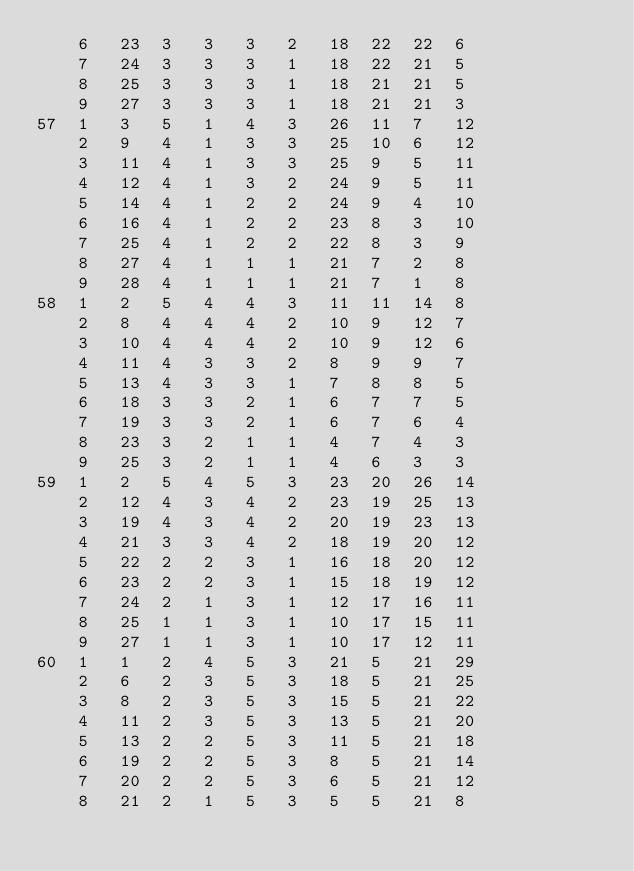<code> <loc_0><loc_0><loc_500><loc_500><_ObjectiveC_>	6	23	3	3	3	2	18	22	22	6	
	7	24	3	3	3	1	18	22	21	5	
	8	25	3	3	3	1	18	21	21	5	
	9	27	3	3	3	1	18	21	21	3	
57	1	3	5	1	4	3	26	11	7	12	
	2	9	4	1	3	3	25	10	6	12	
	3	11	4	1	3	3	25	9	5	11	
	4	12	4	1	3	2	24	9	5	11	
	5	14	4	1	2	2	24	9	4	10	
	6	16	4	1	2	2	23	8	3	10	
	7	25	4	1	2	2	22	8	3	9	
	8	27	4	1	1	1	21	7	2	8	
	9	28	4	1	1	1	21	7	1	8	
58	1	2	5	4	4	3	11	11	14	8	
	2	8	4	4	4	2	10	9	12	7	
	3	10	4	4	4	2	10	9	12	6	
	4	11	4	3	3	2	8	9	9	7	
	5	13	4	3	3	1	7	8	8	5	
	6	18	3	3	2	1	6	7	7	5	
	7	19	3	3	2	1	6	7	6	4	
	8	23	3	2	1	1	4	7	4	3	
	9	25	3	2	1	1	4	6	3	3	
59	1	2	5	4	5	3	23	20	26	14	
	2	12	4	3	4	2	23	19	25	13	
	3	19	4	3	4	2	20	19	23	13	
	4	21	3	3	4	2	18	19	20	12	
	5	22	2	2	3	1	16	18	20	12	
	6	23	2	2	3	1	15	18	19	12	
	7	24	2	1	3	1	12	17	16	11	
	8	25	1	1	3	1	10	17	15	11	
	9	27	1	1	3	1	10	17	12	11	
60	1	1	2	4	5	3	21	5	21	29	
	2	6	2	3	5	3	18	5	21	25	
	3	8	2	3	5	3	15	5	21	22	
	4	11	2	3	5	3	13	5	21	20	
	5	13	2	2	5	3	11	5	21	18	
	6	19	2	2	5	3	8	5	21	14	
	7	20	2	2	5	3	6	5	21	12	
	8	21	2	1	5	3	5	5	21	8	</code> 